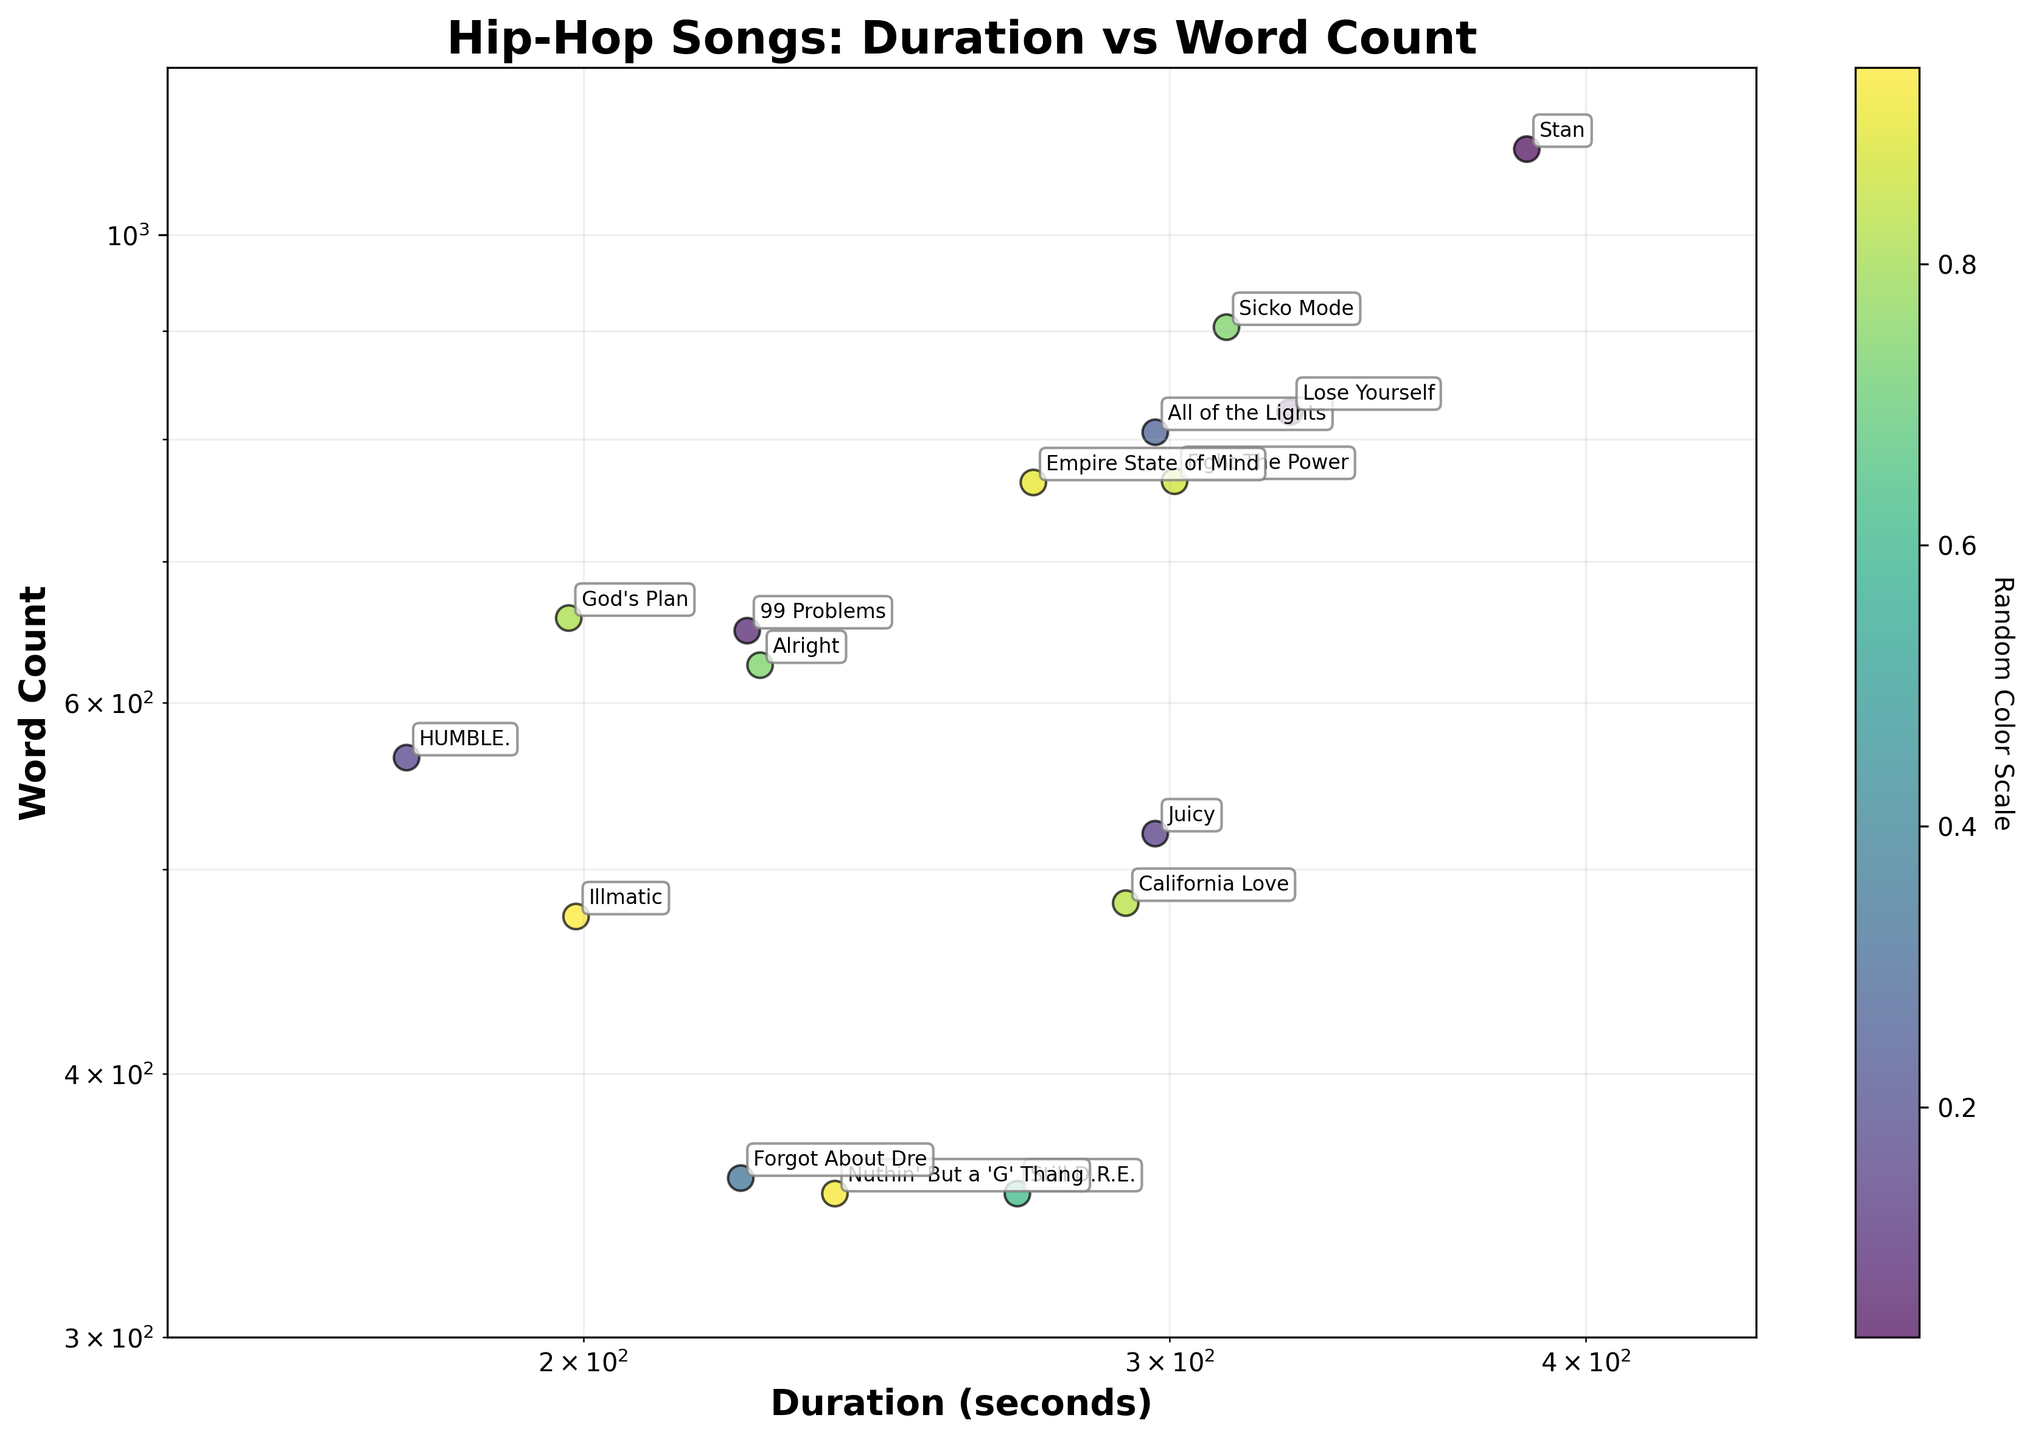What's the title of the plot? The title is located at the top of the plot and typically gives a concise description of what the data represents. In this case, the title directly indicates the relationship between song duration and word count for hip-hop songs.
Answer: Hip-Hop Songs: Duration vs Word Count What's on the x-axis and y-axis? The axes labels provide information about the variables represented in the plot. The x-axis label, located below the horizontal axis, shows duration in seconds, while the y-axis label, located beside the vertical axis, shows the word count.
Answer: x-axis: Duration (seconds), y-axis: Word Count How many songs have a word count greater than 800? By scanning the data points on the y-axis (word count) above 800 and counting the points, we can determine how many songs meet this criterion.
Answer: 4 Which song has the highest word count? To find the song with the highest word count, look at the data point that is placed highest on the y-axis (word count) and refer to the annotation.
Answer: Stan What is the duration of "Lose Yourself"? Locate the point labeled "Lose Yourself" and check its position on the x-axis (duration).
Answer: 326 seconds Are there more songs with a duration greater than 300 seconds or less than 200 seconds? Compare the number of data points positioned to the right of the 300-second mark on the x-axis with those to the left of the 200-second mark.
Answer: More songs with a duration greater than 300 seconds Which two songs have the closest durations but significantly different word counts? Look for two data points that are horizontally close to each other (same x-axis position) but far apart vertically (different y-axis positions) and check the annotations.
Answer: California Love and All of the Lights What's the relationship between duration and word count based on the plot's trendline? Observing the overall distribution of points and any visible trends can help interpret the relationship between x-axis and y-axis variables, i.e., duration and word count. If points are generally rising or falling together, there's a correlation.
Answer: No clear correlation 